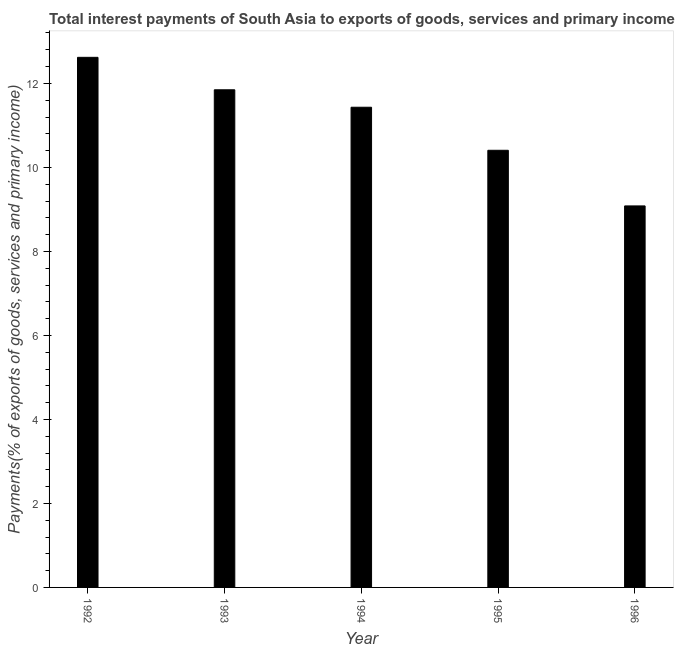Does the graph contain grids?
Your answer should be compact. No. What is the title of the graph?
Your answer should be compact. Total interest payments of South Asia to exports of goods, services and primary income. What is the label or title of the X-axis?
Give a very brief answer. Year. What is the label or title of the Y-axis?
Ensure brevity in your answer.  Payments(% of exports of goods, services and primary income). What is the total interest payments on external debt in 1993?
Provide a short and direct response. 11.85. Across all years, what is the maximum total interest payments on external debt?
Make the answer very short. 12.62. Across all years, what is the minimum total interest payments on external debt?
Your response must be concise. 9.08. In which year was the total interest payments on external debt maximum?
Your response must be concise. 1992. In which year was the total interest payments on external debt minimum?
Make the answer very short. 1996. What is the sum of the total interest payments on external debt?
Offer a very short reply. 55.39. What is the difference between the total interest payments on external debt in 1994 and 1996?
Offer a very short reply. 2.35. What is the average total interest payments on external debt per year?
Keep it short and to the point. 11.08. What is the median total interest payments on external debt?
Ensure brevity in your answer.  11.43. What is the ratio of the total interest payments on external debt in 1992 to that in 1995?
Give a very brief answer. 1.21. What is the difference between the highest and the second highest total interest payments on external debt?
Keep it short and to the point. 0.77. Is the sum of the total interest payments on external debt in 1993 and 1994 greater than the maximum total interest payments on external debt across all years?
Make the answer very short. Yes. What is the difference between the highest and the lowest total interest payments on external debt?
Ensure brevity in your answer.  3.54. Are all the bars in the graph horizontal?
Offer a very short reply. No. How many years are there in the graph?
Make the answer very short. 5. What is the difference between two consecutive major ticks on the Y-axis?
Provide a succinct answer. 2. Are the values on the major ticks of Y-axis written in scientific E-notation?
Your answer should be very brief. No. What is the Payments(% of exports of goods, services and primary income) of 1992?
Keep it short and to the point. 12.62. What is the Payments(% of exports of goods, services and primary income) of 1993?
Give a very brief answer. 11.85. What is the Payments(% of exports of goods, services and primary income) in 1994?
Offer a terse response. 11.43. What is the Payments(% of exports of goods, services and primary income) in 1995?
Provide a short and direct response. 10.41. What is the Payments(% of exports of goods, services and primary income) of 1996?
Offer a terse response. 9.08. What is the difference between the Payments(% of exports of goods, services and primary income) in 1992 and 1993?
Your answer should be compact. 0.77. What is the difference between the Payments(% of exports of goods, services and primary income) in 1992 and 1994?
Offer a terse response. 1.19. What is the difference between the Payments(% of exports of goods, services and primary income) in 1992 and 1995?
Give a very brief answer. 2.21. What is the difference between the Payments(% of exports of goods, services and primary income) in 1992 and 1996?
Give a very brief answer. 3.54. What is the difference between the Payments(% of exports of goods, services and primary income) in 1993 and 1994?
Make the answer very short. 0.42. What is the difference between the Payments(% of exports of goods, services and primary income) in 1993 and 1995?
Your answer should be compact. 1.44. What is the difference between the Payments(% of exports of goods, services and primary income) in 1993 and 1996?
Make the answer very short. 2.77. What is the difference between the Payments(% of exports of goods, services and primary income) in 1994 and 1995?
Your answer should be very brief. 1.02. What is the difference between the Payments(% of exports of goods, services and primary income) in 1994 and 1996?
Your answer should be compact. 2.35. What is the difference between the Payments(% of exports of goods, services and primary income) in 1995 and 1996?
Give a very brief answer. 1.32. What is the ratio of the Payments(% of exports of goods, services and primary income) in 1992 to that in 1993?
Ensure brevity in your answer.  1.06. What is the ratio of the Payments(% of exports of goods, services and primary income) in 1992 to that in 1994?
Your answer should be compact. 1.1. What is the ratio of the Payments(% of exports of goods, services and primary income) in 1992 to that in 1995?
Your response must be concise. 1.21. What is the ratio of the Payments(% of exports of goods, services and primary income) in 1992 to that in 1996?
Keep it short and to the point. 1.39. What is the ratio of the Payments(% of exports of goods, services and primary income) in 1993 to that in 1994?
Offer a very short reply. 1.04. What is the ratio of the Payments(% of exports of goods, services and primary income) in 1993 to that in 1995?
Your response must be concise. 1.14. What is the ratio of the Payments(% of exports of goods, services and primary income) in 1993 to that in 1996?
Make the answer very short. 1.3. What is the ratio of the Payments(% of exports of goods, services and primary income) in 1994 to that in 1995?
Make the answer very short. 1.1. What is the ratio of the Payments(% of exports of goods, services and primary income) in 1994 to that in 1996?
Your answer should be compact. 1.26. What is the ratio of the Payments(% of exports of goods, services and primary income) in 1995 to that in 1996?
Provide a succinct answer. 1.15. 